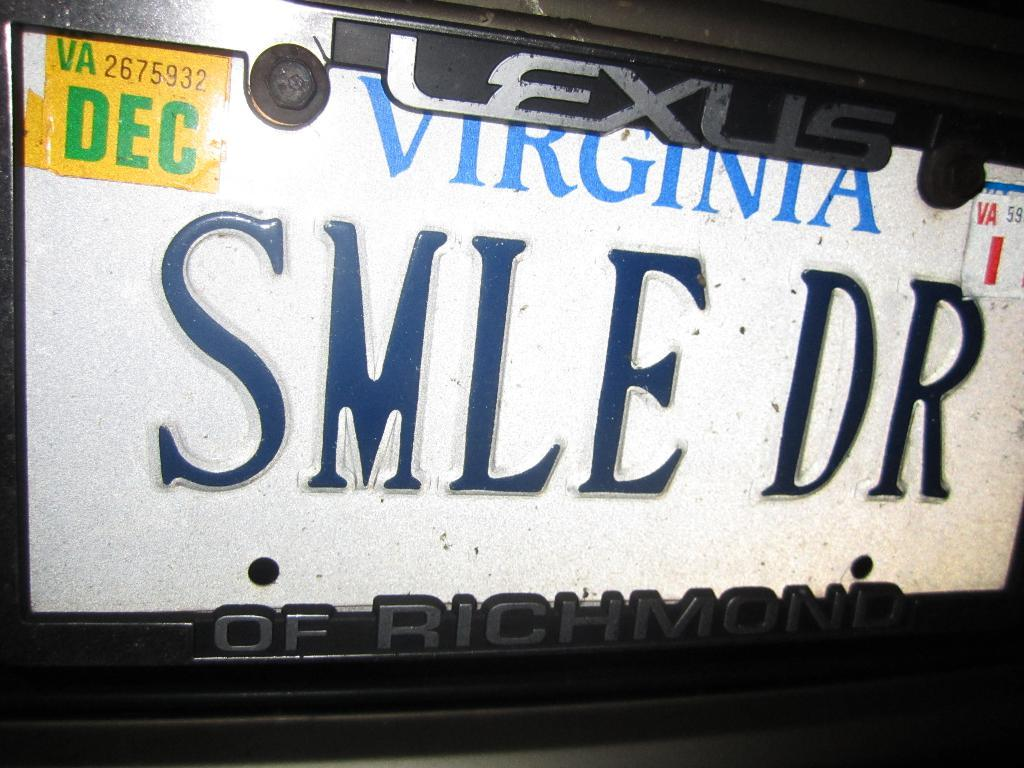<image>
Provide a brief description of the given image. A Virginia license plate has a Lexus of Richmond frame. 